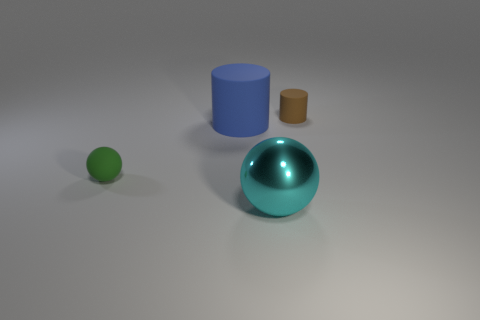Add 3 gray cubes. How many objects exist? 7 Subtract 1 brown cylinders. How many objects are left? 3 Subtract all green cylinders. Subtract all brown balls. How many cylinders are left? 2 Subtract all red cylinders. How many green balls are left? 1 Subtract all small green objects. Subtract all cylinders. How many objects are left? 1 Add 4 cyan metal spheres. How many cyan metal spheres are left? 5 Add 3 large blue matte things. How many large blue matte things exist? 4 